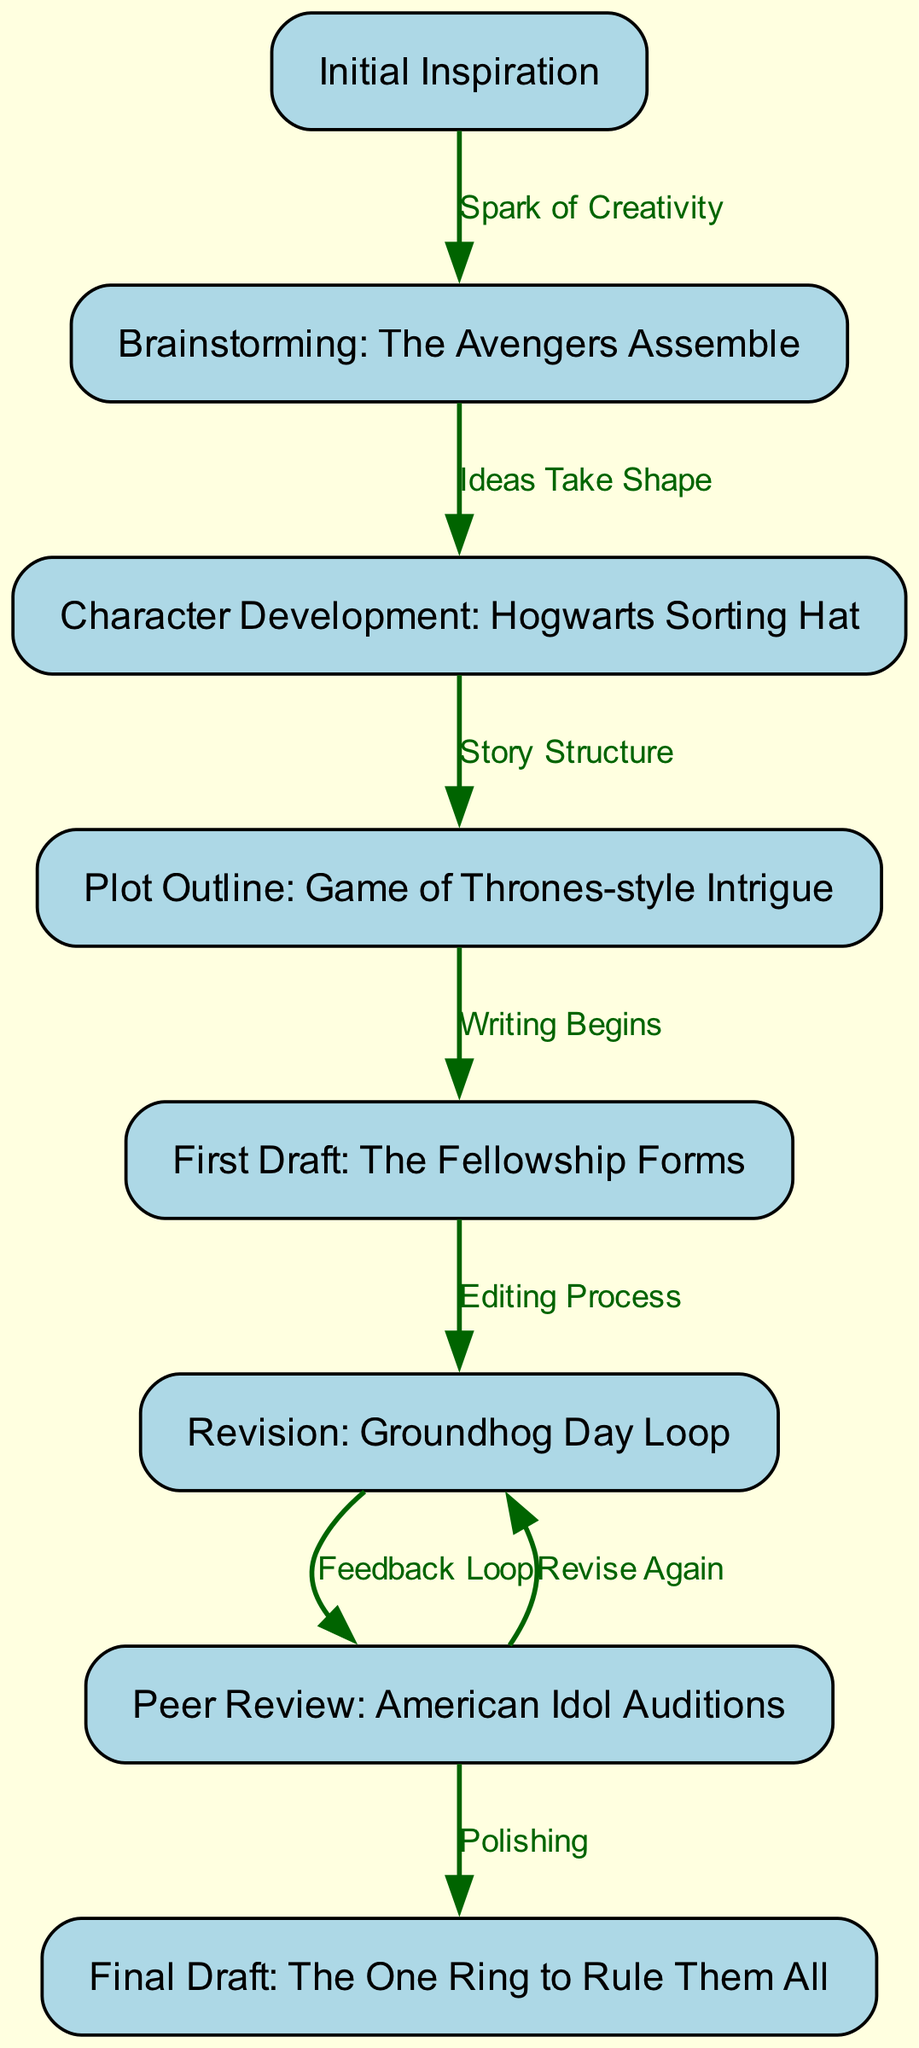What is the first step in the creative writing process? The diagram begins with the node labeled "Initial Inspiration," which signifies the starting point of developing a creative writing piece.
Answer: Initial Inspiration How many nodes are there in the diagram? By counting all the individual labeled nodes in the diagram provided, there are a total of eight distinct nodes representing various stages of the creative writing process.
Answer: 8 What is the relationship between "First Draft" and "Revision"? In the flowchart, there is a directed edge from "First Draft" to "Revision," indicating that the editing process comes after completing the first draft, which shows a sequential relationship.
Answer: Editing Process Which pop culture reference is used in the character development stage? The node for character development features the reference to "Hogwarts Sorting Hat," which indicates the selection and development of characters as inspired by the popular Harry Potter series.
Answer: Hogwarts Sorting Hat What are the two possible actions after the peer review step? The diagram displays two outgoing edges from the "Peer Review" node: one leading to "Final Draft" indicating the polishing step, and another leading back to "Revision," suggesting that additional revisions may be necessary following peer feedback.
Answer: Polishing and Revise Again Which step indicates that the actual writing begins? The node labeled "Plot Outline: Game of Thrones-style Intrigue" connects to the "First Draft" node, denoting that the writing process commences proactively after outlining the plot.
Answer: Writing Begins What stage is referenced with the American Idol metaphor? The "Peer Review" node directly references "American Idol Auditions," illustrating the process of seeking and receiving feedback on a draft similarly to how contestants perform for judges on American Idol.
Answer: American Idol Auditions How does "Character Development" relate to "Plot Outline"? There is a directed edge from "Character Development" to "Plot Outline," signifying that understanding the characters is essential and directly contributes to formulating the story structure.
Answer: Story Structure 